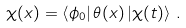<formula> <loc_0><loc_0><loc_500><loc_500>\chi ( x ) = \left \langle \phi _ { 0 } \right | \theta ( x ) \left | \chi ( t ) \right \rangle \, .</formula> 